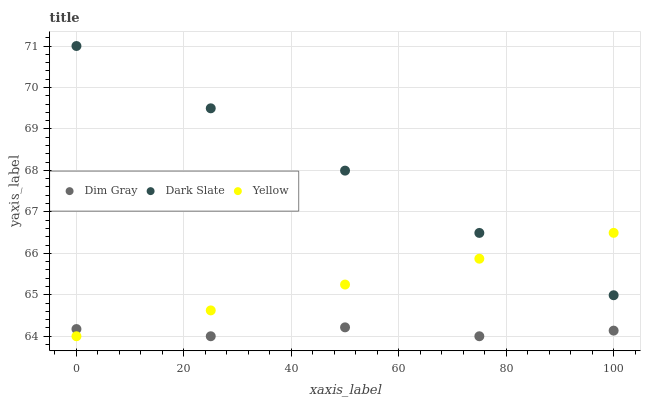Does Dim Gray have the minimum area under the curve?
Answer yes or no. Yes. Does Dark Slate have the maximum area under the curve?
Answer yes or no. Yes. Does Yellow have the minimum area under the curve?
Answer yes or no. No. Does Yellow have the maximum area under the curve?
Answer yes or no. No. Is Yellow the smoothest?
Answer yes or no. Yes. Is Dim Gray the roughest?
Answer yes or no. Yes. Is Dim Gray the smoothest?
Answer yes or no. No. Is Yellow the roughest?
Answer yes or no. No. Does Dim Gray have the lowest value?
Answer yes or no. Yes. Does Dark Slate have the highest value?
Answer yes or no. Yes. Does Yellow have the highest value?
Answer yes or no. No. Is Dim Gray less than Dark Slate?
Answer yes or no. Yes. Is Dark Slate greater than Dim Gray?
Answer yes or no. Yes. Does Yellow intersect Dark Slate?
Answer yes or no. Yes. Is Yellow less than Dark Slate?
Answer yes or no. No. Is Yellow greater than Dark Slate?
Answer yes or no. No. Does Dim Gray intersect Dark Slate?
Answer yes or no. No. 